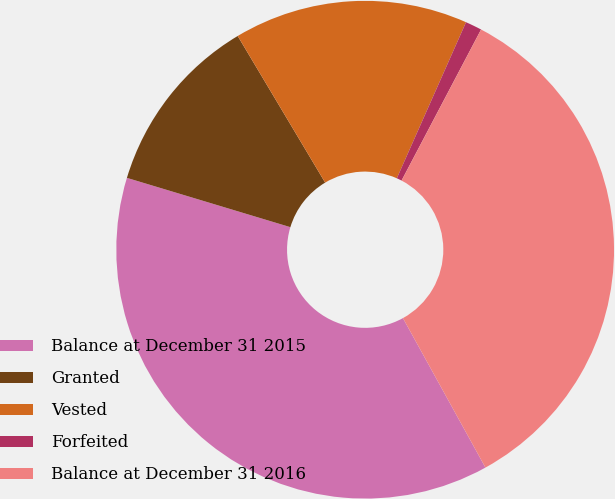<chart> <loc_0><loc_0><loc_500><loc_500><pie_chart><fcel>Balance at December 31 2015<fcel>Granted<fcel>Vested<fcel>Forfeited<fcel>Balance at December 31 2016<nl><fcel>37.69%<fcel>11.78%<fcel>15.2%<fcel>1.07%<fcel>34.26%<nl></chart> 